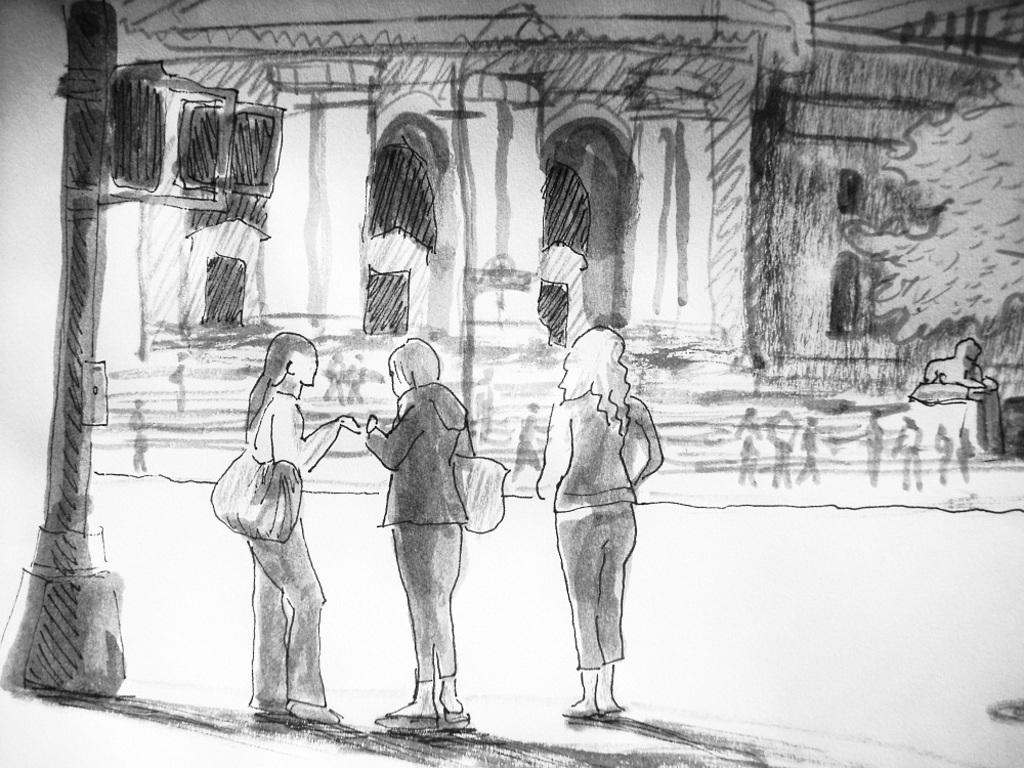What is the main subject of the image? There is a painting in the image. What else can be seen in the image besides the painting? There is a pole, women standing, a body of water, wax, a building, and a tree in the image. How are the women related to the painting in the image? There is no information provided about the relationship between the women and the painting in the image. --- Facts: 1. There is a car in the image. 2. The car is red. 3. There are people in the car. 4. The car has four wheels. 5. The car has a license plate. Absurd Topics: dance, rainbow, ocean Conversation: What is the color of the car in the image? The car is red. How many people are in the car? There are people in the car. What is the number of wheels on the car? The car has four wheels. Is there any identification on the car? Yes, the car has a license plate. Reasoning: Let's think step by step in order to produce the conversation. We start by identifying the main subject of the image, which is the car. Then, we describe specific features of the car, such as its color, the number of people inside, the number of wheels, and the presence of a license plate. Each question is designed to elicit a specific detail about the image that is known from the provided facts. Absurd Question/Answer: Can you see a rainbow in the image? There is no mention of a rainbow in the image; it features a red car with people inside. 